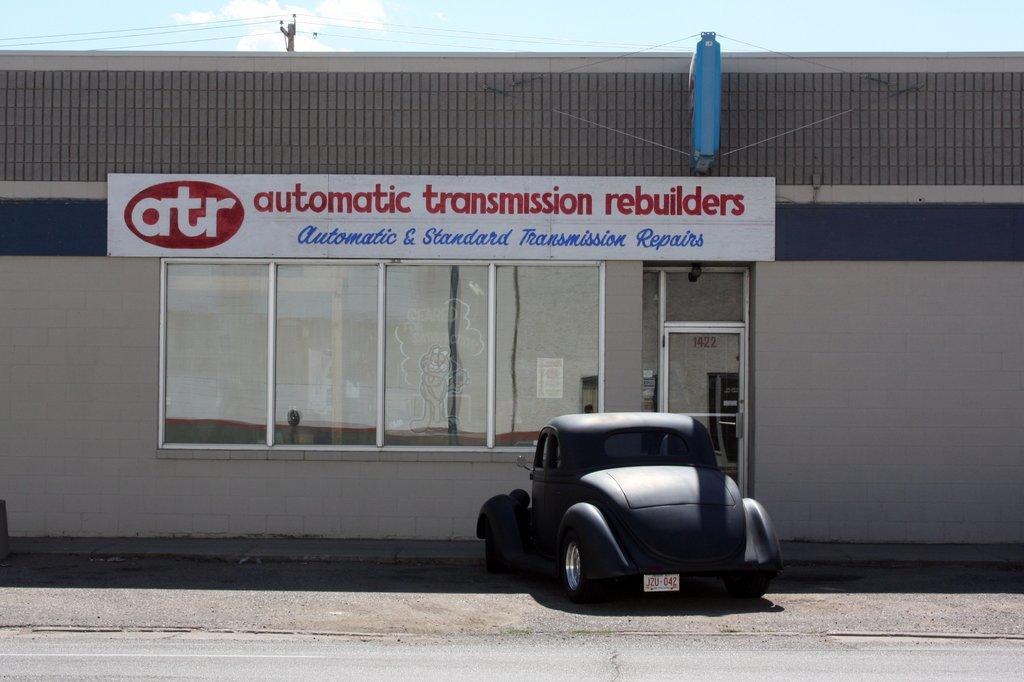In one or two sentences, can you explain what this image depicts? In the picture we can see a building with a glass windows to it and a glass door and on the top of the window we can see a name automatic transmission, rebuilders and near the building we can see a car which is black in color and it is a vintage car and behind the building we can see a pole with electric wires and a sky with clouds. 